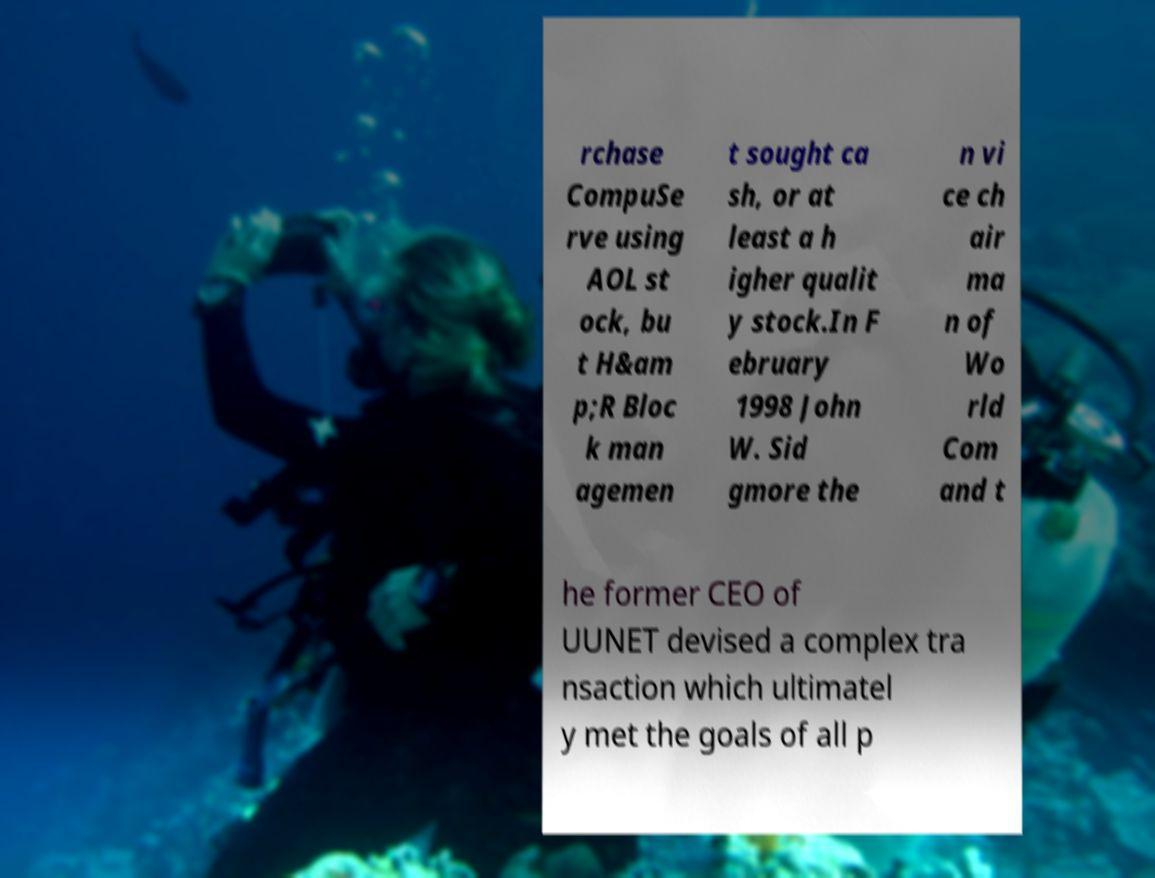Could you extract and type out the text from this image? rchase CompuSe rve using AOL st ock, bu t H&am p;R Bloc k man agemen t sought ca sh, or at least a h igher qualit y stock.In F ebruary 1998 John W. Sid gmore the n vi ce ch air ma n of Wo rld Com and t he former CEO of UUNET devised a complex tra nsaction which ultimatel y met the goals of all p 